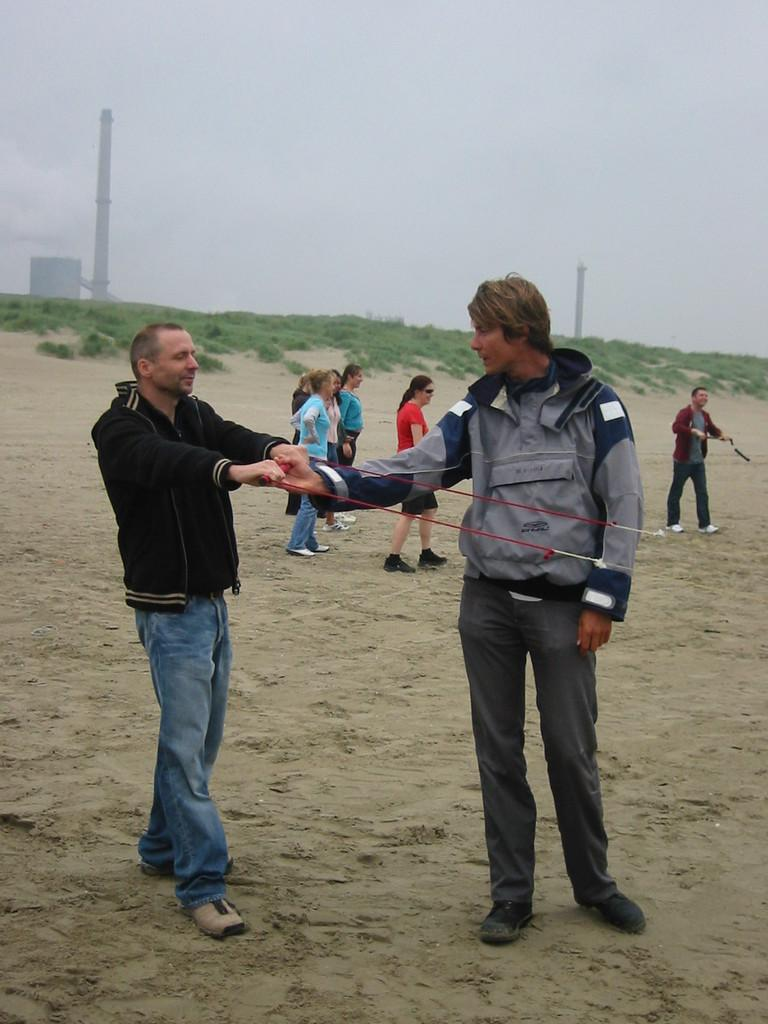How many people are in the image? There are people in the image, but the exact number is not specified. What is on the ground in the image? There is a stand on the ground in the image. What are the two persons holding? The two persons are holding ropes. What can be seen in the background of the image? There are pillars and the sky visible in the background. What type of dog can be seen playing with a wire in the image? There is no dog or wire present in the image. Is there a picture of a landscape hanging on the pillars in the background? The facts provided do not mention any pictures or landscapes, so we cannot determine if there is a picture hanging on the pillars. 